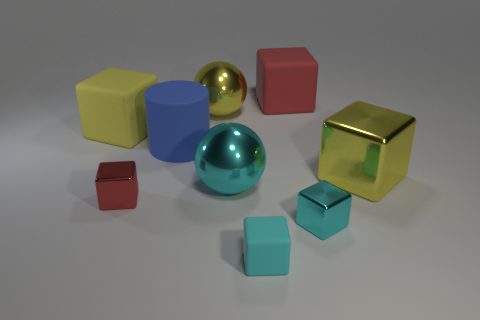There is a ball that is the same color as the large metallic cube; what size is it?
Ensure brevity in your answer.  Large. What shape is the small cyan thing that is on the left side of the small metal thing to the right of the red metallic thing?
Provide a succinct answer. Cube. Is the ball on the left side of the big cyan metallic object made of the same material as the big blue cylinder?
Provide a succinct answer. No. What number of purple objects are either rubber cylinders or matte objects?
Provide a succinct answer. 0. Are there any shiny things of the same color as the big cylinder?
Provide a short and direct response. No. Is there a purple sphere made of the same material as the blue thing?
Offer a very short reply. No. The shiny object that is both on the right side of the cyan ball and behind the red shiny cube has what shape?
Make the answer very short. Cube. What number of small objects are gray objects or red things?
Give a very brief answer. 1. What is the material of the small red cube?
Make the answer very short. Metal. How many other things are the same shape as the large cyan metal thing?
Ensure brevity in your answer.  1. 